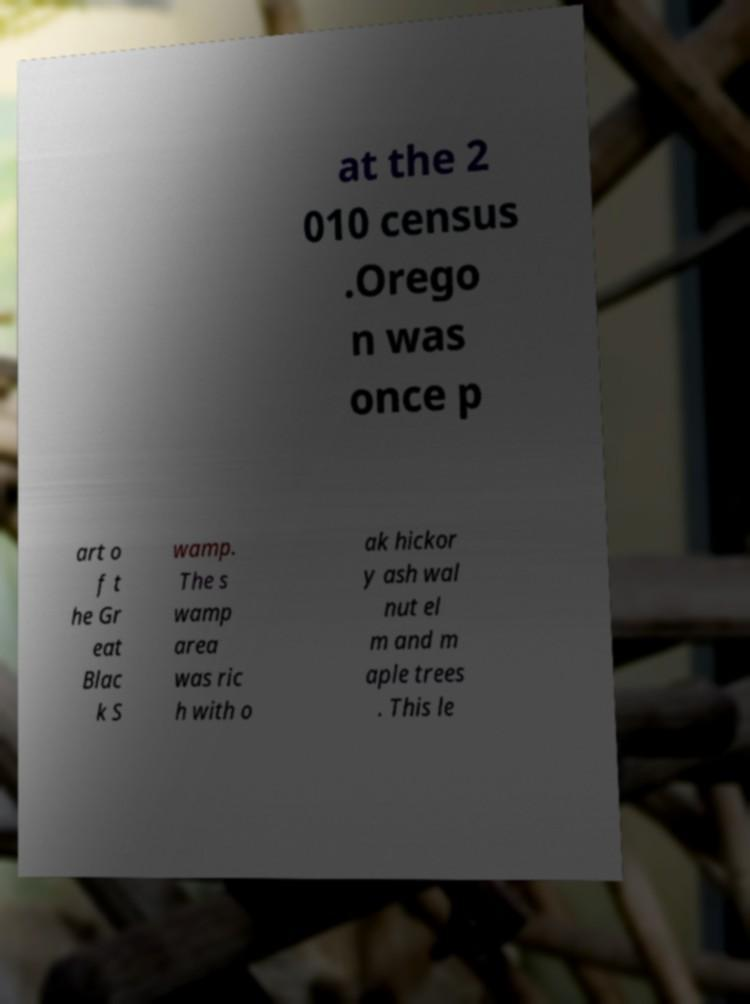Please read and relay the text visible in this image. What does it say? at the 2 010 census .Orego n was once p art o f t he Gr eat Blac k S wamp. The s wamp area was ric h with o ak hickor y ash wal nut el m and m aple trees . This le 